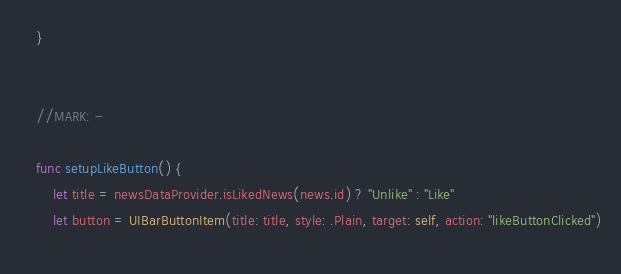<code> <loc_0><loc_0><loc_500><loc_500><_Swift_>    }
    
    
    //MARK: -
    
    func setupLikeButton() {
        let title = newsDataProvider.isLikedNews(news.id) ? "Unlike" : "Like"
        let button = UIBarButtonItem(title: title, style: .Plain, target: self, action: "likeButtonClicked")
        </code> 